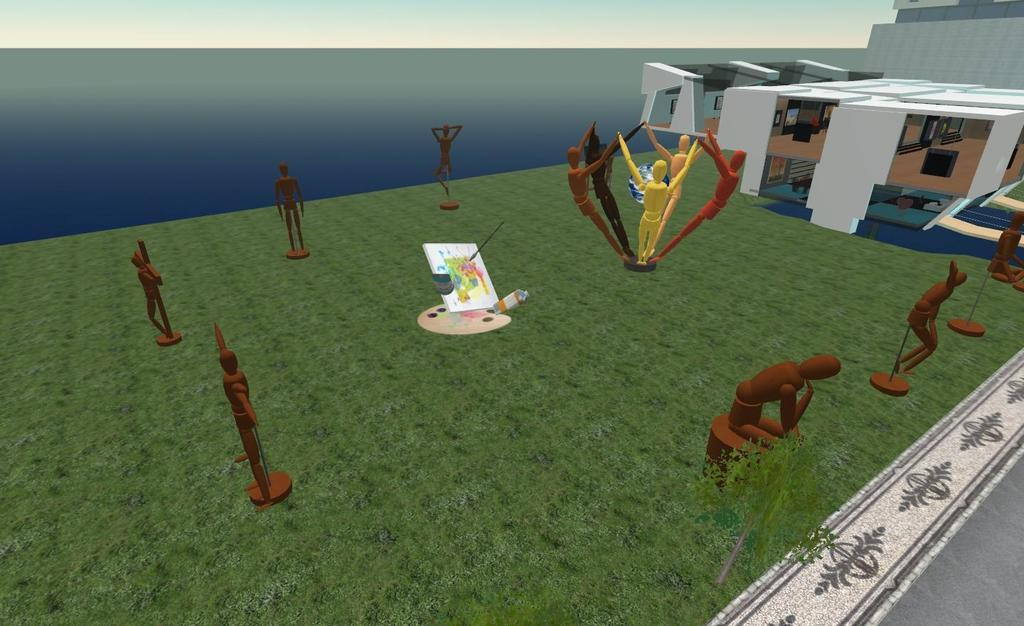What type of art is present in the image? There are sculptures in the image. What color are the sculptures? The sculptures are brown in color. What type of vegetation can be seen in the image? There is grass visible in the image. What type of structure is on the right side of the image? There is a house on the right side of the image. What can be seen in the background of the image? There is water and the sky visible in the background of the image. What type of fruit is being used to create the sculptures in the image? There is no fruit present in the image; the sculptures are made of a different material, likely stone or metal. Is there a playground visible in the image? No, there is no playground present in the image. 